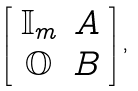Convert formula to latex. <formula><loc_0><loc_0><loc_500><loc_500>\left [ \begin{array} { c c } \mathbb { I } _ { m } & A \\ \mathbb { O } & B \end{array} \right ] ,</formula> 